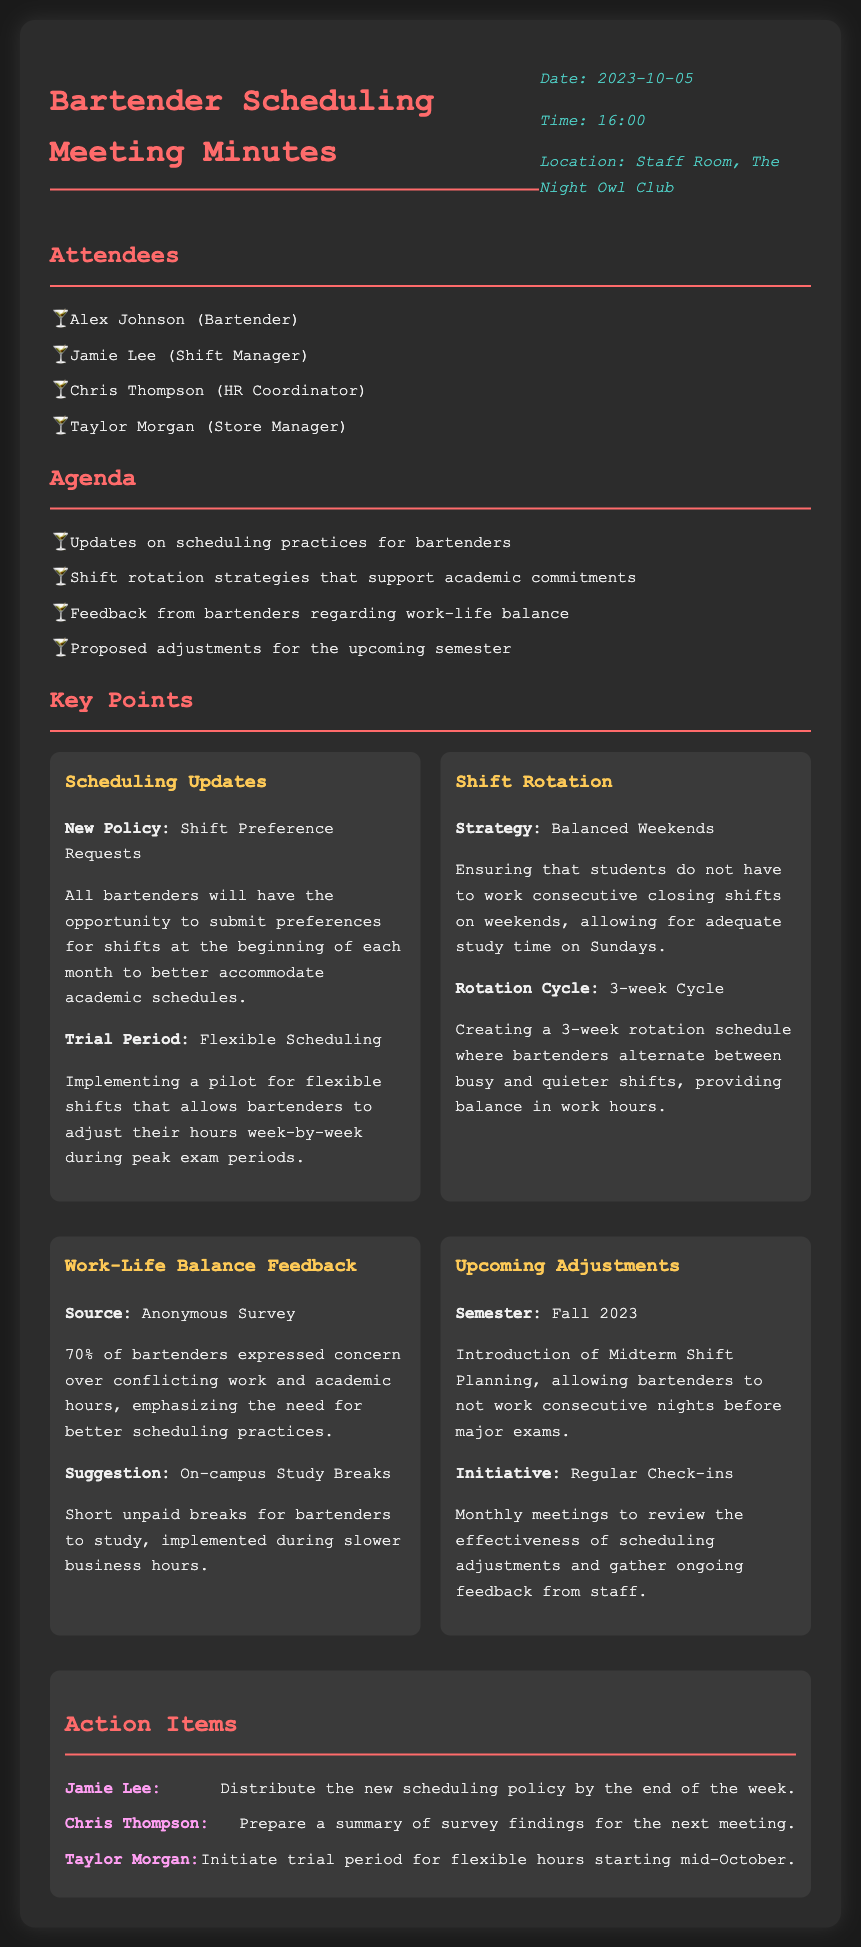What date was the meeting held? The date of the meeting is specified in the document, which is October 5, 2023.
Answer: October 5, 2023 Who is responsible for distributing the new scheduling policy? The action item lists Jamie Lee as the person responsible for distributing the new scheduling policy.
Answer: Jamie Lee What percentage of bartenders expressed concern over their work and academic hours? The document mentions that 70% of bartenders shared this concern in an anonymous survey.
Answer: 70% What is the proposed shift rotation cycle? The key point regarding shift rotation specifies a 3-week cycle for bartenders.
Answer: 3-week Cycle What initiative is planned to start in mid-October? The document includes an action item stating that Taylor Morgan will initiate a trial period for flexible hours starting mid-October.
Answer: Trial period for flexible hours How often will regular check-ins occur? The key points indicate that the meetings for reviewing scheduling adjustments will happen monthly.
Answer: Monthly What was the main concern for bartenders mentioned in the anonymous survey? The feedback section discusses bartenders' concerns regarding conflicting work and academic hours.
Answer: Conflicting work and academic hours What is the main purpose of the 'Midterm Shift Planning'? The key points outline that the purpose is to allow bartenders not to work consecutive nights before major exams.
Answer: Not work consecutive nights before major exams 